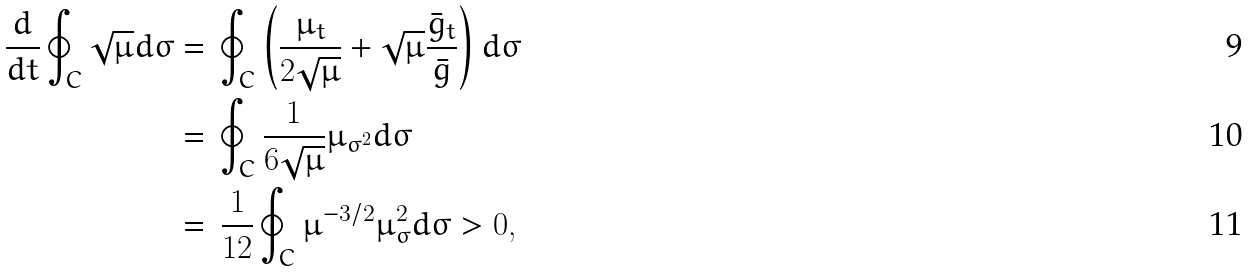Convert formula to latex. <formula><loc_0><loc_0><loc_500><loc_500>\frac { d } { d t } \oint _ { C } \sqrt { \mu } d \sigma & = \, \oint _ { C } \left ( \frac { \mu _ { t } } { 2 \sqrt { \mu } } + \sqrt { \mu } \frac { \bar { g } _ { t } } { \bar { g } } \right ) d \sigma \\ & = \, \oint _ { C } \frac { 1 } { 6 \sqrt { \mu } } \mu _ { \sigma ^ { 2 } } d \sigma \\ & = \, \frac { 1 } { 1 2 } \oint _ { C } \mu ^ { - 3 / 2 } \mu _ { \sigma } ^ { 2 } d \sigma > 0 ,</formula> 